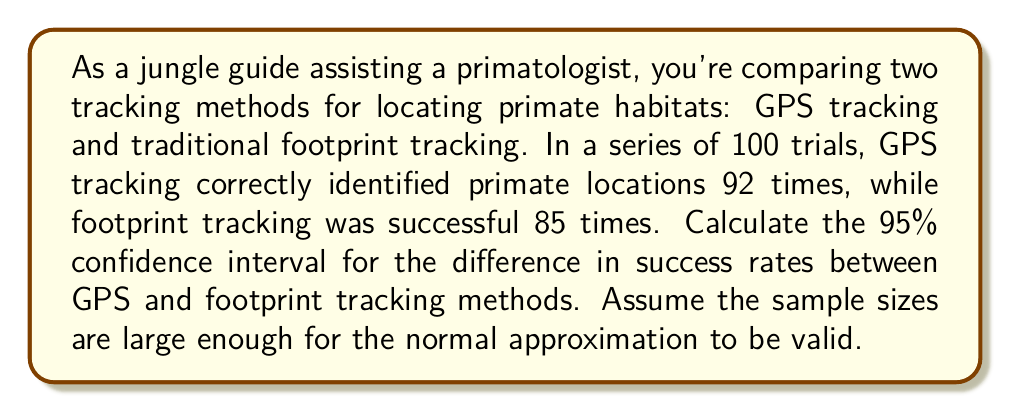Can you answer this question? Let's approach this step-by-step:

1) Define the parameters:
   $p_1$ = true proportion for GPS tracking success
   $p_2$ = true proportion for footprint tracking success
   $\hat{p}_1 = 92/100 = 0.92$ (sample proportion for GPS)
   $\hat{p}_2 = 85/100 = 0.85$ (sample proportion for footprint)
   $n_1 = n_2 = 100$ (sample sizes)

2) The point estimate for the difference in proportions is:
   $\hat{p}_1 - \hat{p}_2 = 0.92 - 0.85 = 0.07$

3) For a 95% confidence interval, we use $z_{\alpha/2} = 1.96$

4) The standard error for the difference in proportions is:
   $$SE = \sqrt{\frac{\hat{p}_1(1-\hat{p}_1)}{n_1} + \frac{\hat{p}_2(1-\hat{p}_2)}{n_2}}$$
   $$SE = \sqrt{\frac{0.92(1-0.92)}{100} + \frac{0.85(1-0.85)}{100}}$$
   $$SE = \sqrt{0.000736 + 0.001275} = \sqrt{0.002011} \approx 0.0448$$

5) The 95% confidence interval is given by:
   $$(\hat{p}_1 - \hat{p}_2) \pm z_{\alpha/2} \cdot SE$$
   $$0.07 \pm 1.96 \cdot 0.0448$$
   $$0.07 \pm 0.0878$$

6) Therefore, the 95% confidence interval is:
   $$(0.07 - 0.0878, 0.07 + 0.0878) = (-0.0178, 0.1578)$$
Answer: (-0.0178, 0.1578) 